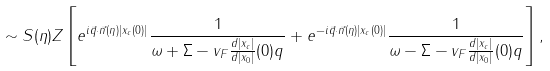<formula> <loc_0><loc_0><loc_500><loc_500>\sim S ( \eta ) Z \left [ e ^ { i \vec { q } \cdot \vec { n } ( \eta ) | x _ { c } ( 0 ) | } \frac { 1 } { \omega + \Sigma - v _ { F } \frac { d | x _ { c } | } { d | x _ { 0 } | } ( 0 ) q _ { \| } } + e ^ { - i \vec { q } \cdot \vec { n } ( \eta ) | x _ { c } ( 0 ) | } \frac { 1 } { \omega - \Sigma - v _ { F } \frac { d | x _ { c } | } { d | x _ { 0 } | } ( 0 ) q _ { \| } } \right ] ,</formula> 